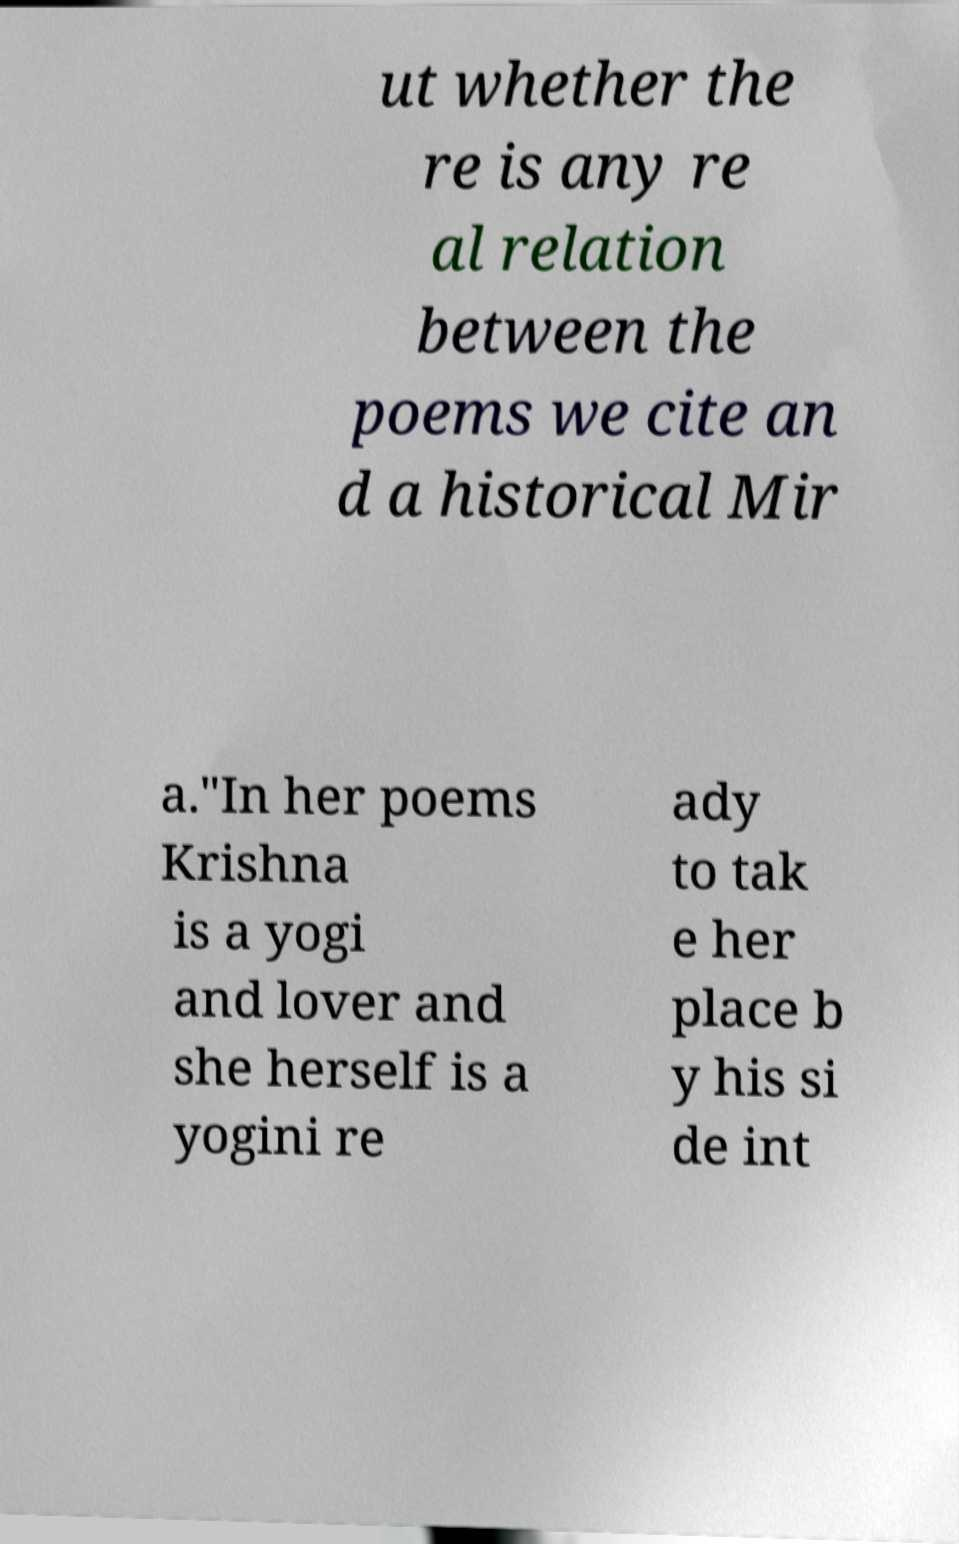I need the written content from this picture converted into text. Can you do that? ut whether the re is any re al relation between the poems we cite an d a historical Mir a."In her poems Krishna is a yogi and lover and she herself is a yogini re ady to tak e her place b y his si de int 